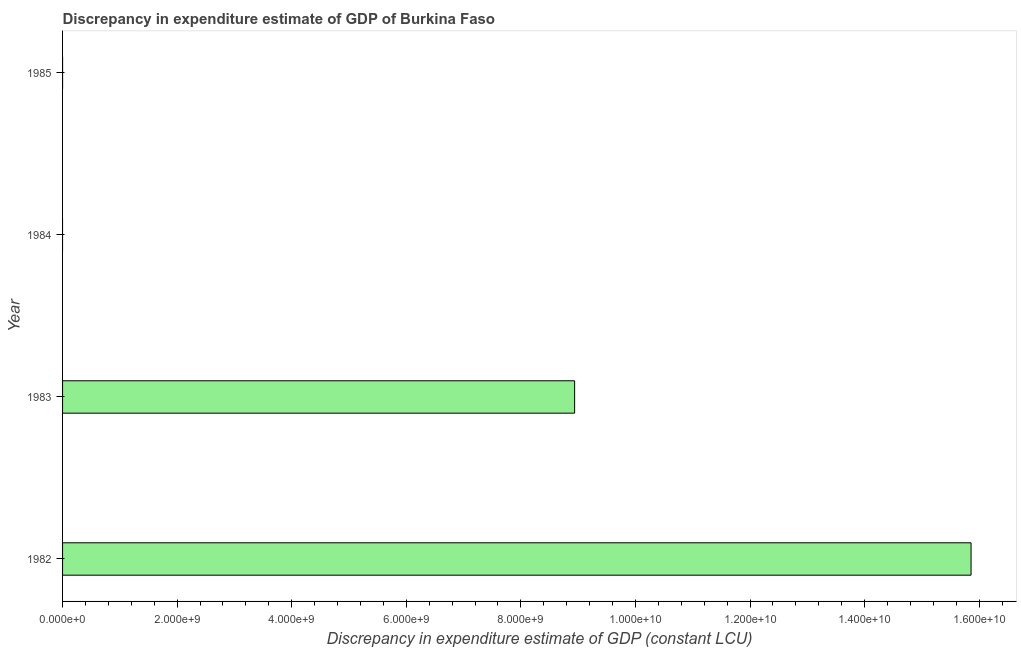What is the title of the graph?
Your answer should be very brief. Discrepancy in expenditure estimate of GDP of Burkina Faso. What is the label or title of the X-axis?
Make the answer very short. Discrepancy in expenditure estimate of GDP (constant LCU). What is the label or title of the Y-axis?
Make the answer very short. Year. What is the discrepancy in expenditure estimate of gdp in 1982?
Your response must be concise. 1.59e+1. Across all years, what is the maximum discrepancy in expenditure estimate of gdp?
Your answer should be very brief. 1.59e+1. What is the sum of the discrepancy in expenditure estimate of gdp?
Your response must be concise. 2.48e+1. What is the difference between the discrepancy in expenditure estimate of gdp in 1982 and 1983?
Offer a very short reply. 6.92e+09. What is the average discrepancy in expenditure estimate of gdp per year?
Give a very brief answer. 6.20e+09. What is the median discrepancy in expenditure estimate of gdp?
Make the answer very short. 4.47e+09. What is the ratio of the discrepancy in expenditure estimate of gdp in 1982 to that in 1983?
Give a very brief answer. 1.77. What is the difference between the highest and the lowest discrepancy in expenditure estimate of gdp?
Provide a short and direct response. 1.59e+1. How many bars are there?
Offer a very short reply. 2. How many years are there in the graph?
Make the answer very short. 4. What is the difference between two consecutive major ticks on the X-axis?
Give a very brief answer. 2.00e+09. What is the Discrepancy in expenditure estimate of GDP (constant LCU) in 1982?
Offer a very short reply. 1.59e+1. What is the Discrepancy in expenditure estimate of GDP (constant LCU) of 1983?
Provide a succinct answer. 8.94e+09. What is the Discrepancy in expenditure estimate of GDP (constant LCU) in 1985?
Keep it short and to the point. 0. What is the difference between the Discrepancy in expenditure estimate of GDP (constant LCU) in 1982 and 1983?
Your response must be concise. 6.92e+09. What is the ratio of the Discrepancy in expenditure estimate of GDP (constant LCU) in 1982 to that in 1983?
Provide a succinct answer. 1.77. 